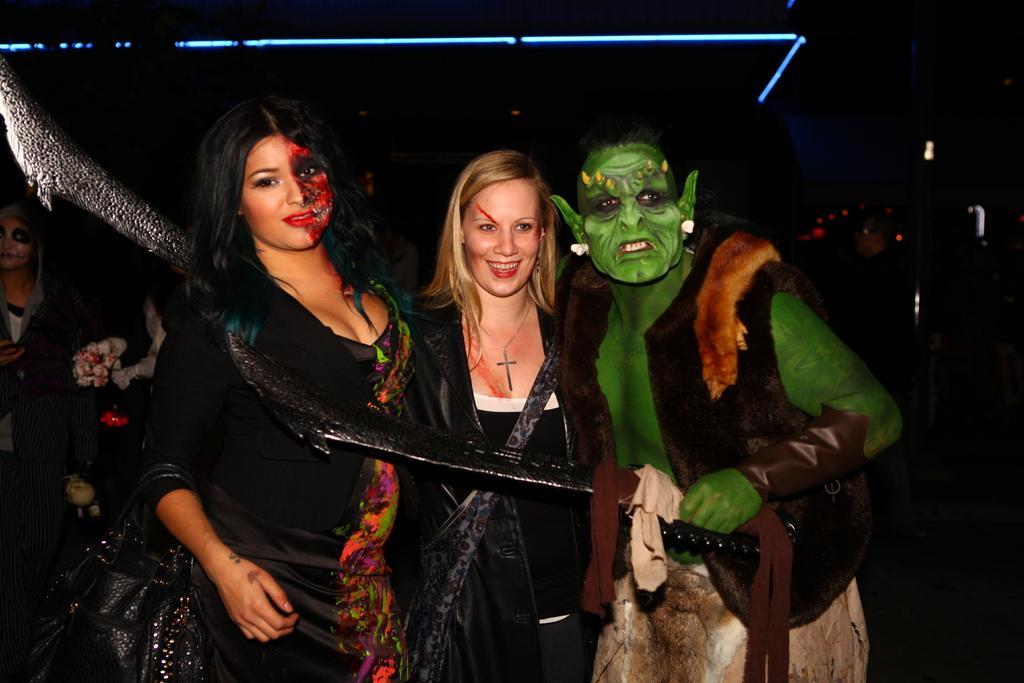In one or two sentences, can you explain what this image depicts? In this I can see few people are standing and I can see painting on their faces and looks like a tree on the back. 